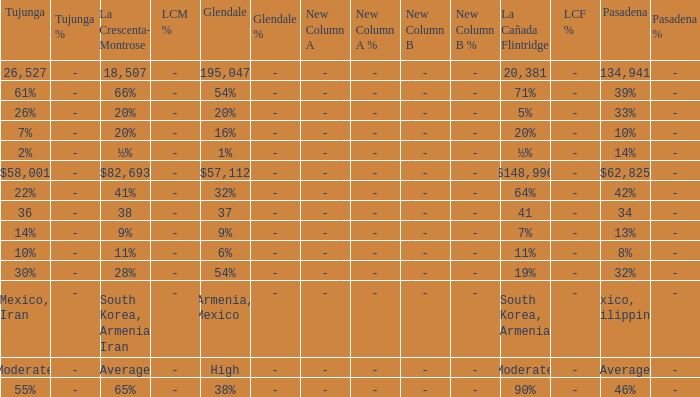What is the figure for Pasadena when Tujunga is 36? 34.0. 